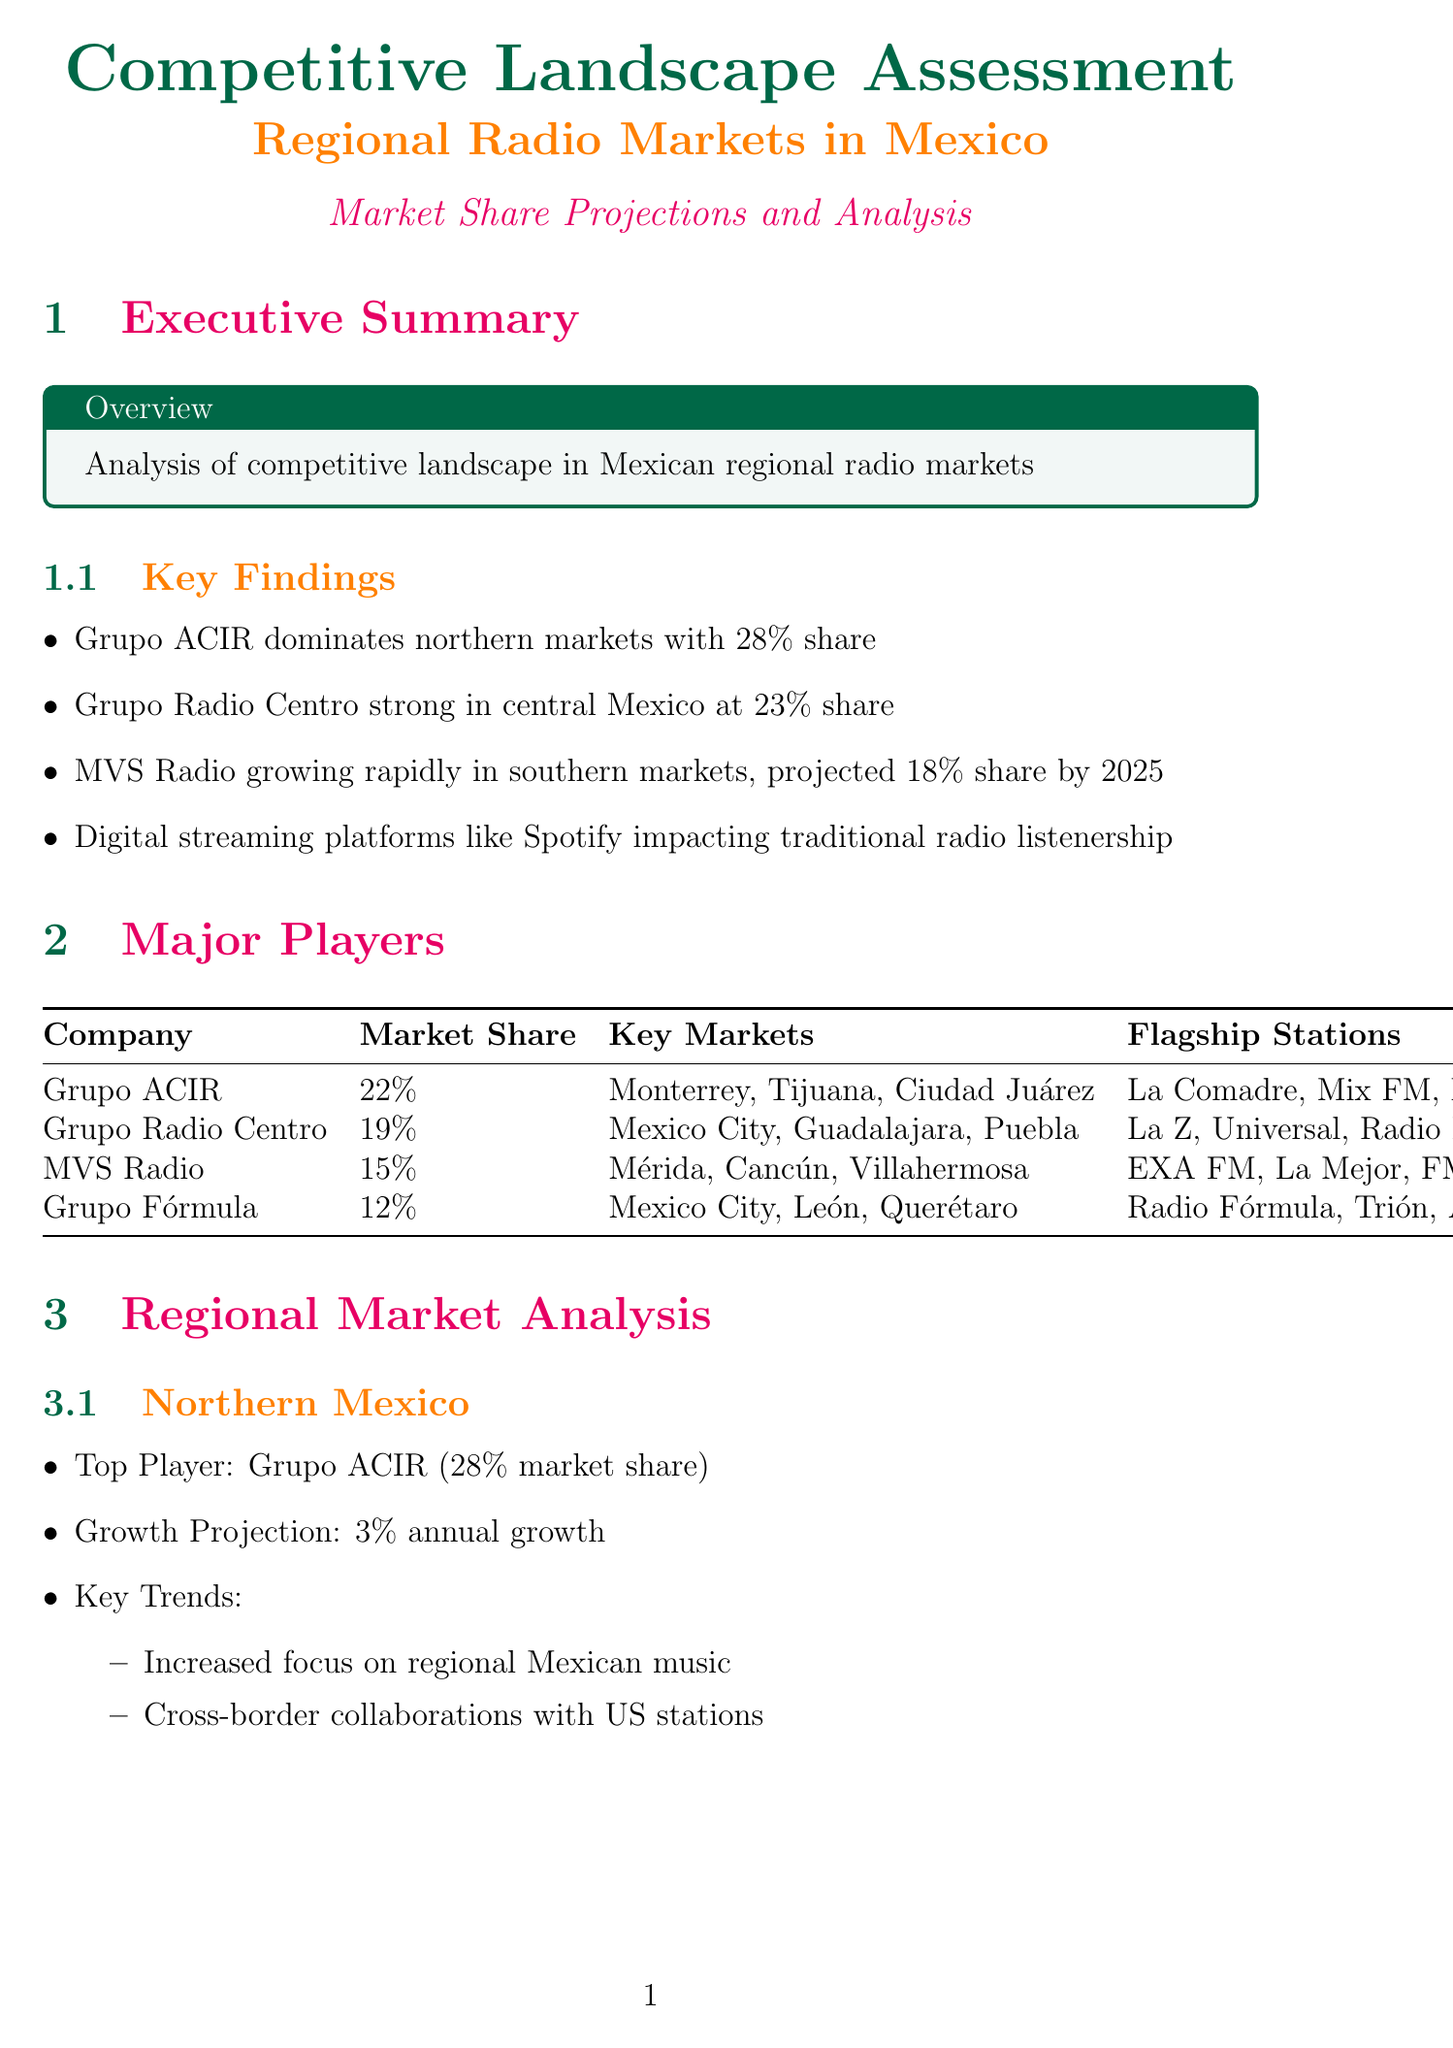What company dominates northern Mexico radio markets? Grupo ACIR is identified as the top player in northern Mexico radio markets in the report.
Answer: Grupo ACIR What is the projected market share for Grupo Radio Centro in 2025? The document states that the projected market share for Grupo Radio Centro by 2025 is recorded in the market share projections section.
Answer: 21% Which region shows the highest annual growth projection? The document outlines annual growth projections for different regions, indicating the southern market has the highest.
Answer: Southern Mexico What percentage of the market share does MVS Radio currently hold? The document provides specific market share percentages for major players in the radio market, including MVS Radio.
Answer: 15% What is one of the key trends in Central Mexico radio? The report lists key trends for various regions, specifically noting the emphasis in Central Mexico on a particular direction.
Answer: Integration of digital platforms Which competition strategy involves podcasts and specialized programming? The competitive strategies section of the document highlights a particular strategy that includes expanding programming types.
Answer: Content Diversification What is the primary regulatory body overseeing radio in Mexico? The document mentions key regulations affecting the radio industry, identifying the federal agency in charge.
Answer: Federal Telecommunications Institute What is one challenge facing traditional radio mentioned in the report? The challenges section notes multiple difficulties for traditional radio, focusing on competition from other audio platforms.
Answer: Competition from digital streaming platforms What technology trend involves smart speakers? The technological trends section of the report identifies innovations in the industry, including specific technology involving household devices.
Answer: Integration of voice-activated smart speakers 